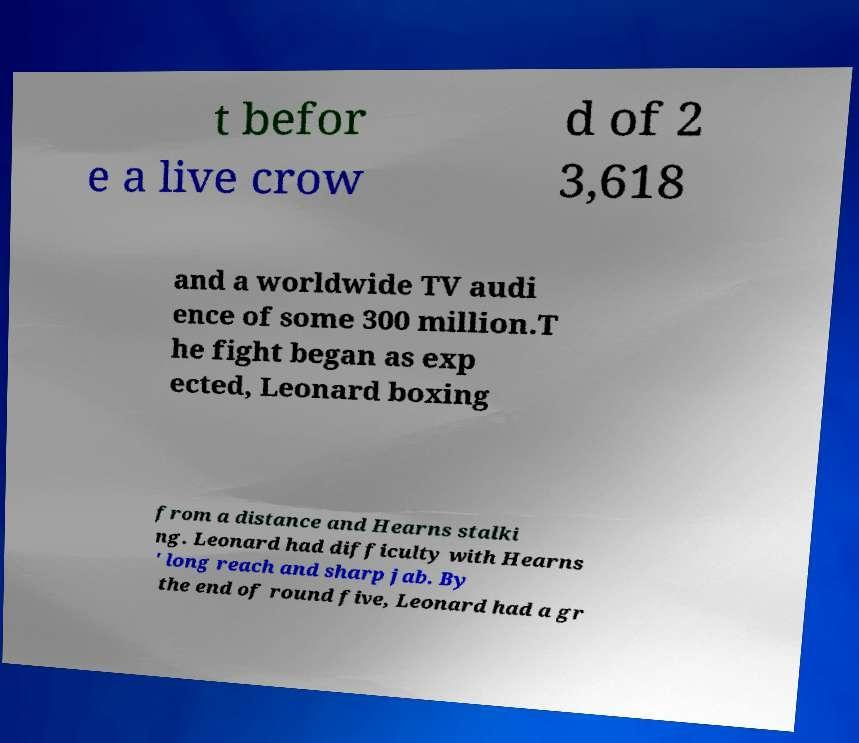What messages or text are displayed in this image? I need them in a readable, typed format. t befor e a live crow d of 2 3,618 and a worldwide TV audi ence of some 300 million.T he fight began as exp ected, Leonard boxing from a distance and Hearns stalki ng. Leonard had difficulty with Hearns ' long reach and sharp jab. By the end of round five, Leonard had a gr 